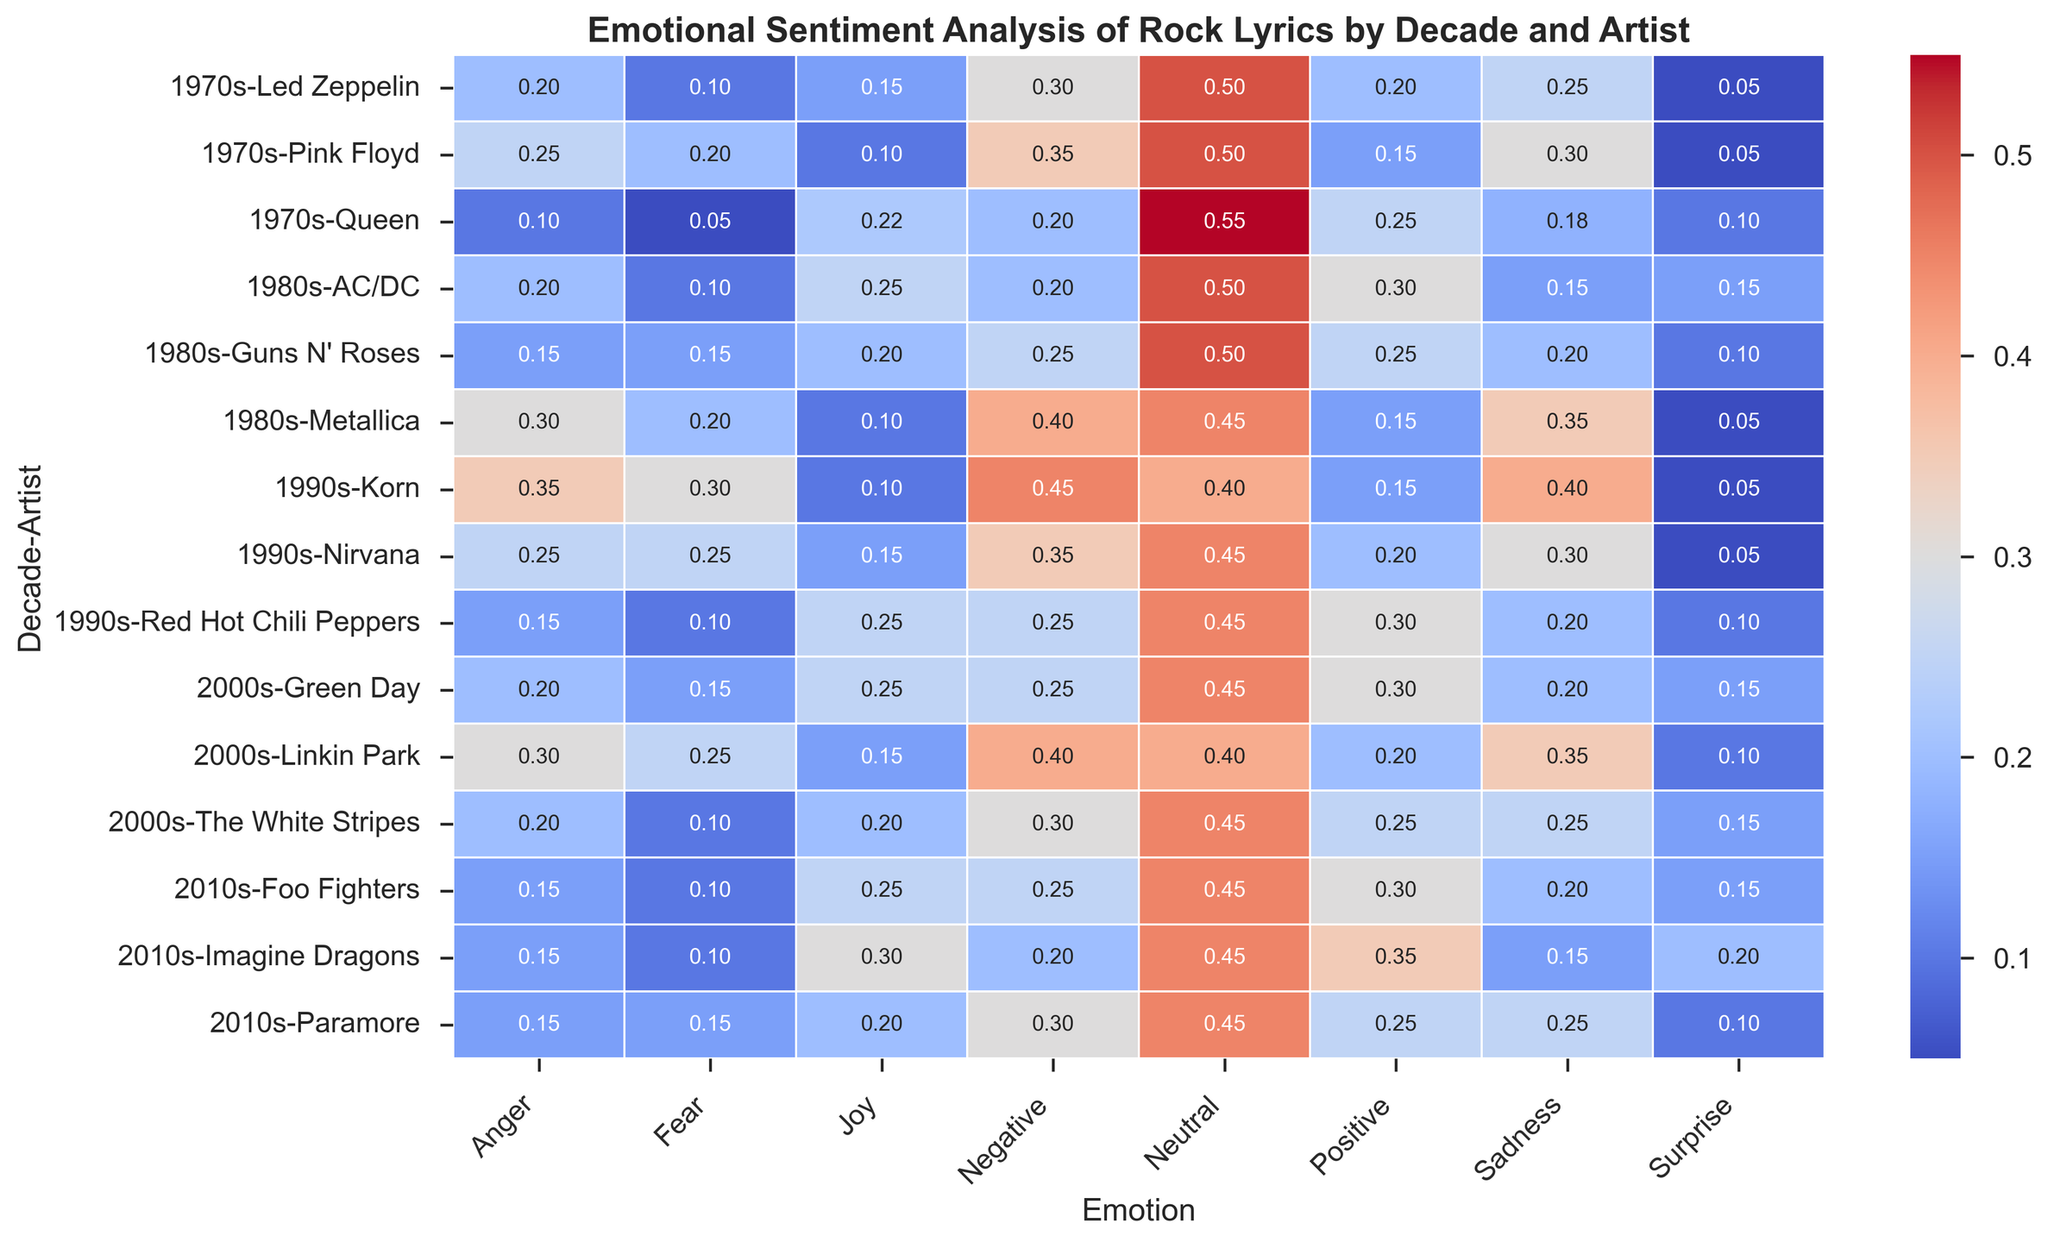Which artist from the 1990s has the highest percentage of negative sentiment? Observe the heatmap for the 1990s decade. Compare the negative sentiment values for Nirvana, Red Hot Chili Peppers, and Korn. The highest value is for Korn.
Answer: Korn Which decade shows the highest average positive sentiment for all artists combined? Calculate the average positive sentiment for each decade, averaging the sentiment values of all artists within each decade. Comparing these averages, the 2010s have the highest value.
Answer: 2010s Which artist shows the highest joy sentiment across all decades? Scan through the joy sentiment values for all artists and find the highest value, which belongs to Imagine Dragons in the 2010s.
Answer: Imagine Dragons How does the negative sentiment of Korn in the 1990s compare to Metallica in the 1980s? Locate Korn's negative sentiment in the 1990s and Metallica's negative sentiment in the 1980s. Compare 0.45 (Korn) to 0.40 (Metallica). Korn's negative sentiment is higher.
Answer: Korn's negative sentiment is higher What is the sum of the fear sentiment percentages for Led Zeppelin in the 1970s and Nirvana in the 1990s? Add the fear sentiment values for Led Zeppelin (0.10) and Nirvana (0.25). 0.10 + 0.25 equals 0.35.
Answer: 0.35 Which artist has the greatest difference between joy and sadness sentiments in the 2000s? Calculate the absolute difference between joy and sadness for Linkin Park, Green Day, and The White Stripes in the 2000s. The greatest difference is for Green Day:
Answer: Green Day Which artist in the 2010s has a similar emotional sentiment profile to Queen in the 1970s? Compare the emotional sentiment values (positive, negative, neutral, joy, sadness, anger, fear, surprise) of each 2010s artist with those of Queen. Imagine Dragons have a similar distribution of values.
Answer: Imagine Dragons What is the average joy sentiment across all decades? Calculate the average joy sentiment by summing the joy values for all artists and dividing by the number of artists (15). The sum is 0.15+0.22+0.10+0.25+0.10+0.20+0.15+0.25+0.10+0.15+0.25+0.20+0.30+0.25+0.20 = 2.67. The average is 2.67/15 = 0.178.
Answer: 0.178 